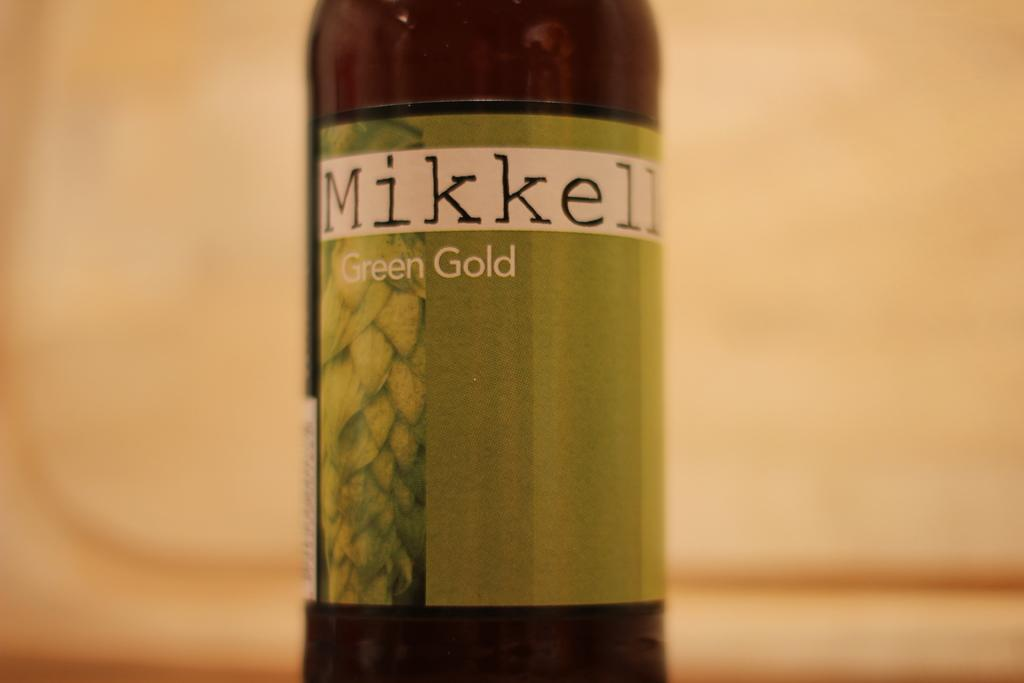What object can be seen in the image? There is a bottle in the image. What type of kitty is knitting with wool in the image? There is no kitty or wool present in the image; it only features a bottle. 